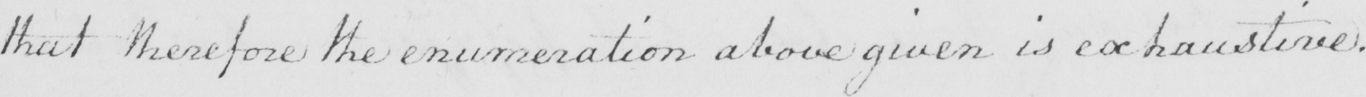Please transcribe the handwritten text in this image. that therefore the enumeration above given is exhaustive . 